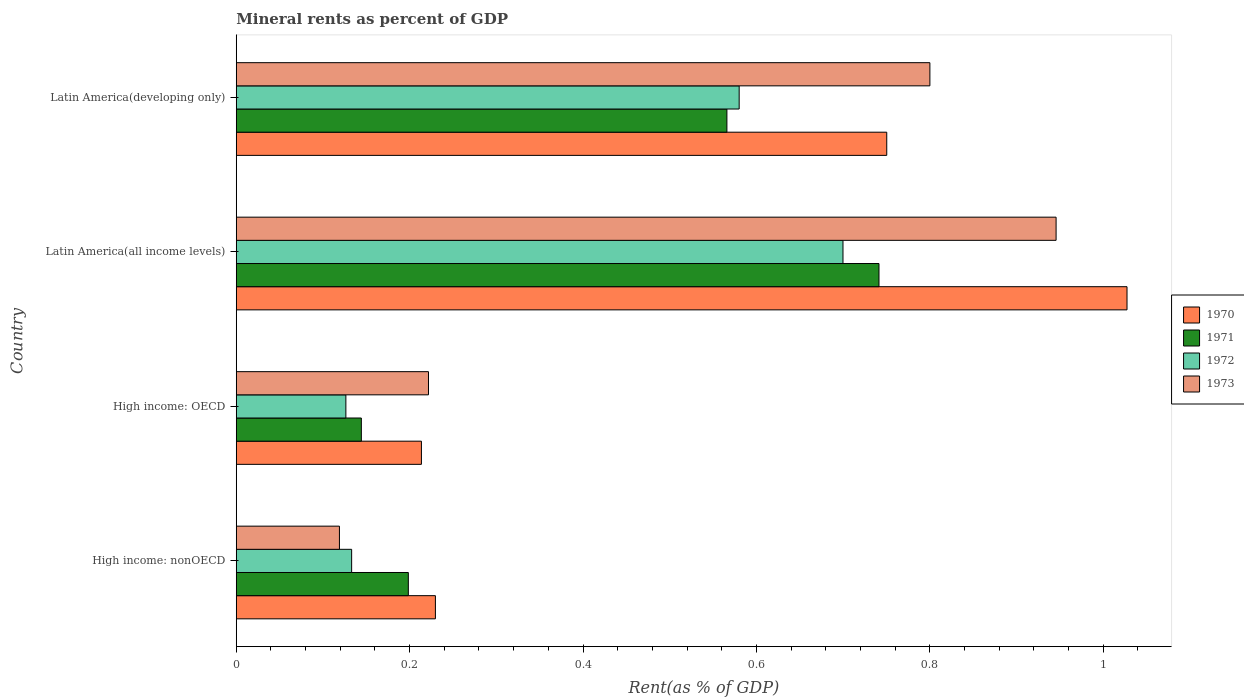Are the number of bars per tick equal to the number of legend labels?
Give a very brief answer. Yes. Are the number of bars on each tick of the Y-axis equal?
Ensure brevity in your answer.  Yes. How many bars are there on the 3rd tick from the top?
Ensure brevity in your answer.  4. What is the label of the 1st group of bars from the top?
Give a very brief answer. Latin America(developing only). In how many cases, is the number of bars for a given country not equal to the number of legend labels?
Keep it short and to the point. 0. What is the mineral rent in 1973 in Latin America(all income levels)?
Your answer should be compact. 0.95. Across all countries, what is the maximum mineral rent in 1971?
Your answer should be compact. 0.74. Across all countries, what is the minimum mineral rent in 1972?
Your answer should be compact. 0.13. In which country was the mineral rent in 1973 maximum?
Give a very brief answer. Latin America(all income levels). In which country was the mineral rent in 1971 minimum?
Give a very brief answer. High income: OECD. What is the total mineral rent in 1971 in the graph?
Provide a succinct answer. 1.65. What is the difference between the mineral rent in 1971 in High income: OECD and that in High income: nonOECD?
Give a very brief answer. -0.05. What is the difference between the mineral rent in 1970 in Latin America(developing only) and the mineral rent in 1972 in High income: nonOECD?
Your answer should be compact. 0.62. What is the average mineral rent in 1970 per country?
Make the answer very short. 0.56. What is the difference between the mineral rent in 1971 and mineral rent in 1972 in Latin America(all income levels)?
Provide a short and direct response. 0.04. What is the ratio of the mineral rent in 1971 in Latin America(all income levels) to that in Latin America(developing only)?
Your answer should be compact. 1.31. Is the mineral rent in 1972 in High income: OECD less than that in Latin America(developing only)?
Give a very brief answer. Yes. What is the difference between the highest and the second highest mineral rent in 1973?
Provide a short and direct response. 0.15. What is the difference between the highest and the lowest mineral rent in 1972?
Give a very brief answer. 0.57. In how many countries, is the mineral rent in 1973 greater than the average mineral rent in 1973 taken over all countries?
Provide a short and direct response. 2. Is the sum of the mineral rent in 1973 in High income: OECD and Latin America(all income levels) greater than the maximum mineral rent in 1972 across all countries?
Keep it short and to the point. Yes. What does the 3rd bar from the top in Latin America(all income levels) represents?
Make the answer very short. 1971. Is it the case that in every country, the sum of the mineral rent in 1971 and mineral rent in 1973 is greater than the mineral rent in 1972?
Your answer should be very brief. Yes. How many countries are there in the graph?
Provide a succinct answer. 4. What is the difference between two consecutive major ticks on the X-axis?
Keep it short and to the point. 0.2. Are the values on the major ticks of X-axis written in scientific E-notation?
Your response must be concise. No. Does the graph contain any zero values?
Provide a succinct answer. No. Where does the legend appear in the graph?
Provide a succinct answer. Center right. How many legend labels are there?
Make the answer very short. 4. How are the legend labels stacked?
Your answer should be very brief. Vertical. What is the title of the graph?
Your response must be concise. Mineral rents as percent of GDP. Does "1982" appear as one of the legend labels in the graph?
Make the answer very short. No. What is the label or title of the X-axis?
Offer a very short reply. Rent(as % of GDP). What is the label or title of the Y-axis?
Give a very brief answer. Country. What is the Rent(as % of GDP) of 1970 in High income: nonOECD?
Your response must be concise. 0.23. What is the Rent(as % of GDP) in 1971 in High income: nonOECD?
Keep it short and to the point. 0.2. What is the Rent(as % of GDP) of 1972 in High income: nonOECD?
Your answer should be very brief. 0.13. What is the Rent(as % of GDP) in 1973 in High income: nonOECD?
Offer a very short reply. 0.12. What is the Rent(as % of GDP) of 1970 in High income: OECD?
Give a very brief answer. 0.21. What is the Rent(as % of GDP) of 1971 in High income: OECD?
Make the answer very short. 0.14. What is the Rent(as % of GDP) in 1972 in High income: OECD?
Ensure brevity in your answer.  0.13. What is the Rent(as % of GDP) of 1973 in High income: OECD?
Make the answer very short. 0.22. What is the Rent(as % of GDP) in 1970 in Latin America(all income levels)?
Offer a very short reply. 1.03. What is the Rent(as % of GDP) of 1971 in Latin America(all income levels)?
Your response must be concise. 0.74. What is the Rent(as % of GDP) of 1972 in Latin America(all income levels)?
Ensure brevity in your answer.  0.7. What is the Rent(as % of GDP) of 1973 in Latin America(all income levels)?
Provide a succinct answer. 0.95. What is the Rent(as % of GDP) of 1970 in Latin America(developing only)?
Your answer should be compact. 0.75. What is the Rent(as % of GDP) in 1971 in Latin America(developing only)?
Make the answer very short. 0.57. What is the Rent(as % of GDP) of 1972 in Latin America(developing only)?
Give a very brief answer. 0.58. What is the Rent(as % of GDP) in 1973 in Latin America(developing only)?
Give a very brief answer. 0.8. Across all countries, what is the maximum Rent(as % of GDP) in 1970?
Provide a short and direct response. 1.03. Across all countries, what is the maximum Rent(as % of GDP) of 1971?
Provide a short and direct response. 0.74. Across all countries, what is the maximum Rent(as % of GDP) of 1972?
Give a very brief answer. 0.7. Across all countries, what is the maximum Rent(as % of GDP) in 1973?
Offer a terse response. 0.95. Across all countries, what is the minimum Rent(as % of GDP) of 1970?
Your answer should be compact. 0.21. Across all countries, what is the minimum Rent(as % of GDP) of 1971?
Provide a short and direct response. 0.14. Across all countries, what is the minimum Rent(as % of GDP) of 1972?
Offer a very short reply. 0.13. Across all countries, what is the minimum Rent(as % of GDP) in 1973?
Your answer should be very brief. 0.12. What is the total Rent(as % of GDP) of 1970 in the graph?
Provide a succinct answer. 2.22. What is the total Rent(as % of GDP) in 1971 in the graph?
Make the answer very short. 1.65. What is the total Rent(as % of GDP) in 1972 in the graph?
Give a very brief answer. 1.54. What is the total Rent(as % of GDP) in 1973 in the graph?
Make the answer very short. 2.09. What is the difference between the Rent(as % of GDP) in 1970 in High income: nonOECD and that in High income: OECD?
Your response must be concise. 0.02. What is the difference between the Rent(as % of GDP) of 1971 in High income: nonOECD and that in High income: OECD?
Offer a very short reply. 0.05. What is the difference between the Rent(as % of GDP) of 1972 in High income: nonOECD and that in High income: OECD?
Keep it short and to the point. 0.01. What is the difference between the Rent(as % of GDP) in 1973 in High income: nonOECD and that in High income: OECD?
Offer a very short reply. -0.1. What is the difference between the Rent(as % of GDP) of 1970 in High income: nonOECD and that in Latin America(all income levels)?
Keep it short and to the point. -0.8. What is the difference between the Rent(as % of GDP) in 1971 in High income: nonOECD and that in Latin America(all income levels)?
Offer a terse response. -0.54. What is the difference between the Rent(as % of GDP) of 1972 in High income: nonOECD and that in Latin America(all income levels)?
Give a very brief answer. -0.57. What is the difference between the Rent(as % of GDP) of 1973 in High income: nonOECD and that in Latin America(all income levels)?
Give a very brief answer. -0.83. What is the difference between the Rent(as % of GDP) in 1970 in High income: nonOECD and that in Latin America(developing only)?
Ensure brevity in your answer.  -0.52. What is the difference between the Rent(as % of GDP) of 1971 in High income: nonOECD and that in Latin America(developing only)?
Provide a succinct answer. -0.37. What is the difference between the Rent(as % of GDP) of 1972 in High income: nonOECD and that in Latin America(developing only)?
Your response must be concise. -0.45. What is the difference between the Rent(as % of GDP) of 1973 in High income: nonOECD and that in Latin America(developing only)?
Offer a terse response. -0.68. What is the difference between the Rent(as % of GDP) of 1970 in High income: OECD and that in Latin America(all income levels)?
Your answer should be very brief. -0.81. What is the difference between the Rent(as % of GDP) in 1971 in High income: OECD and that in Latin America(all income levels)?
Provide a succinct answer. -0.6. What is the difference between the Rent(as % of GDP) of 1972 in High income: OECD and that in Latin America(all income levels)?
Your response must be concise. -0.57. What is the difference between the Rent(as % of GDP) in 1973 in High income: OECD and that in Latin America(all income levels)?
Keep it short and to the point. -0.72. What is the difference between the Rent(as % of GDP) in 1970 in High income: OECD and that in Latin America(developing only)?
Give a very brief answer. -0.54. What is the difference between the Rent(as % of GDP) in 1971 in High income: OECD and that in Latin America(developing only)?
Your answer should be very brief. -0.42. What is the difference between the Rent(as % of GDP) in 1972 in High income: OECD and that in Latin America(developing only)?
Offer a terse response. -0.45. What is the difference between the Rent(as % of GDP) of 1973 in High income: OECD and that in Latin America(developing only)?
Your answer should be compact. -0.58. What is the difference between the Rent(as % of GDP) in 1970 in Latin America(all income levels) and that in Latin America(developing only)?
Give a very brief answer. 0.28. What is the difference between the Rent(as % of GDP) of 1971 in Latin America(all income levels) and that in Latin America(developing only)?
Provide a short and direct response. 0.18. What is the difference between the Rent(as % of GDP) of 1972 in Latin America(all income levels) and that in Latin America(developing only)?
Offer a very short reply. 0.12. What is the difference between the Rent(as % of GDP) in 1973 in Latin America(all income levels) and that in Latin America(developing only)?
Your answer should be very brief. 0.15. What is the difference between the Rent(as % of GDP) in 1970 in High income: nonOECD and the Rent(as % of GDP) in 1971 in High income: OECD?
Keep it short and to the point. 0.09. What is the difference between the Rent(as % of GDP) in 1970 in High income: nonOECD and the Rent(as % of GDP) in 1972 in High income: OECD?
Offer a terse response. 0.1. What is the difference between the Rent(as % of GDP) of 1970 in High income: nonOECD and the Rent(as % of GDP) of 1973 in High income: OECD?
Your answer should be very brief. 0.01. What is the difference between the Rent(as % of GDP) in 1971 in High income: nonOECD and the Rent(as % of GDP) in 1972 in High income: OECD?
Offer a very short reply. 0.07. What is the difference between the Rent(as % of GDP) in 1971 in High income: nonOECD and the Rent(as % of GDP) in 1973 in High income: OECD?
Give a very brief answer. -0.02. What is the difference between the Rent(as % of GDP) in 1972 in High income: nonOECD and the Rent(as % of GDP) in 1973 in High income: OECD?
Provide a short and direct response. -0.09. What is the difference between the Rent(as % of GDP) of 1970 in High income: nonOECD and the Rent(as % of GDP) of 1971 in Latin America(all income levels)?
Keep it short and to the point. -0.51. What is the difference between the Rent(as % of GDP) of 1970 in High income: nonOECD and the Rent(as % of GDP) of 1972 in Latin America(all income levels)?
Your answer should be compact. -0.47. What is the difference between the Rent(as % of GDP) in 1970 in High income: nonOECD and the Rent(as % of GDP) in 1973 in Latin America(all income levels)?
Ensure brevity in your answer.  -0.72. What is the difference between the Rent(as % of GDP) of 1971 in High income: nonOECD and the Rent(as % of GDP) of 1972 in Latin America(all income levels)?
Ensure brevity in your answer.  -0.5. What is the difference between the Rent(as % of GDP) in 1971 in High income: nonOECD and the Rent(as % of GDP) in 1973 in Latin America(all income levels)?
Offer a terse response. -0.75. What is the difference between the Rent(as % of GDP) of 1972 in High income: nonOECD and the Rent(as % of GDP) of 1973 in Latin America(all income levels)?
Your answer should be very brief. -0.81. What is the difference between the Rent(as % of GDP) of 1970 in High income: nonOECD and the Rent(as % of GDP) of 1971 in Latin America(developing only)?
Your answer should be compact. -0.34. What is the difference between the Rent(as % of GDP) of 1970 in High income: nonOECD and the Rent(as % of GDP) of 1972 in Latin America(developing only)?
Your response must be concise. -0.35. What is the difference between the Rent(as % of GDP) in 1970 in High income: nonOECD and the Rent(as % of GDP) in 1973 in Latin America(developing only)?
Your response must be concise. -0.57. What is the difference between the Rent(as % of GDP) in 1971 in High income: nonOECD and the Rent(as % of GDP) in 1972 in Latin America(developing only)?
Give a very brief answer. -0.38. What is the difference between the Rent(as % of GDP) of 1971 in High income: nonOECD and the Rent(as % of GDP) of 1973 in Latin America(developing only)?
Provide a short and direct response. -0.6. What is the difference between the Rent(as % of GDP) in 1972 in High income: nonOECD and the Rent(as % of GDP) in 1973 in Latin America(developing only)?
Give a very brief answer. -0.67. What is the difference between the Rent(as % of GDP) of 1970 in High income: OECD and the Rent(as % of GDP) of 1971 in Latin America(all income levels)?
Keep it short and to the point. -0.53. What is the difference between the Rent(as % of GDP) of 1970 in High income: OECD and the Rent(as % of GDP) of 1972 in Latin America(all income levels)?
Make the answer very short. -0.49. What is the difference between the Rent(as % of GDP) of 1970 in High income: OECD and the Rent(as % of GDP) of 1973 in Latin America(all income levels)?
Your answer should be compact. -0.73. What is the difference between the Rent(as % of GDP) in 1971 in High income: OECD and the Rent(as % of GDP) in 1972 in Latin America(all income levels)?
Make the answer very short. -0.56. What is the difference between the Rent(as % of GDP) in 1971 in High income: OECD and the Rent(as % of GDP) in 1973 in Latin America(all income levels)?
Give a very brief answer. -0.8. What is the difference between the Rent(as % of GDP) of 1972 in High income: OECD and the Rent(as % of GDP) of 1973 in Latin America(all income levels)?
Make the answer very short. -0.82. What is the difference between the Rent(as % of GDP) in 1970 in High income: OECD and the Rent(as % of GDP) in 1971 in Latin America(developing only)?
Offer a very short reply. -0.35. What is the difference between the Rent(as % of GDP) in 1970 in High income: OECD and the Rent(as % of GDP) in 1972 in Latin America(developing only)?
Give a very brief answer. -0.37. What is the difference between the Rent(as % of GDP) in 1970 in High income: OECD and the Rent(as % of GDP) in 1973 in Latin America(developing only)?
Your answer should be very brief. -0.59. What is the difference between the Rent(as % of GDP) in 1971 in High income: OECD and the Rent(as % of GDP) in 1972 in Latin America(developing only)?
Make the answer very short. -0.44. What is the difference between the Rent(as % of GDP) in 1971 in High income: OECD and the Rent(as % of GDP) in 1973 in Latin America(developing only)?
Your answer should be compact. -0.66. What is the difference between the Rent(as % of GDP) of 1972 in High income: OECD and the Rent(as % of GDP) of 1973 in Latin America(developing only)?
Give a very brief answer. -0.67. What is the difference between the Rent(as % of GDP) of 1970 in Latin America(all income levels) and the Rent(as % of GDP) of 1971 in Latin America(developing only)?
Ensure brevity in your answer.  0.46. What is the difference between the Rent(as % of GDP) in 1970 in Latin America(all income levels) and the Rent(as % of GDP) in 1972 in Latin America(developing only)?
Your answer should be compact. 0.45. What is the difference between the Rent(as % of GDP) of 1970 in Latin America(all income levels) and the Rent(as % of GDP) of 1973 in Latin America(developing only)?
Your response must be concise. 0.23. What is the difference between the Rent(as % of GDP) in 1971 in Latin America(all income levels) and the Rent(as % of GDP) in 1972 in Latin America(developing only)?
Provide a succinct answer. 0.16. What is the difference between the Rent(as % of GDP) of 1971 in Latin America(all income levels) and the Rent(as % of GDP) of 1973 in Latin America(developing only)?
Keep it short and to the point. -0.06. What is the difference between the Rent(as % of GDP) of 1972 in Latin America(all income levels) and the Rent(as % of GDP) of 1973 in Latin America(developing only)?
Your answer should be very brief. -0.1. What is the average Rent(as % of GDP) in 1970 per country?
Provide a short and direct response. 0.56. What is the average Rent(as % of GDP) in 1971 per country?
Provide a succinct answer. 0.41. What is the average Rent(as % of GDP) in 1972 per country?
Offer a very short reply. 0.38. What is the average Rent(as % of GDP) of 1973 per country?
Provide a short and direct response. 0.52. What is the difference between the Rent(as % of GDP) of 1970 and Rent(as % of GDP) of 1971 in High income: nonOECD?
Offer a terse response. 0.03. What is the difference between the Rent(as % of GDP) in 1970 and Rent(as % of GDP) in 1972 in High income: nonOECD?
Provide a succinct answer. 0.1. What is the difference between the Rent(as % of GDP) in 1970 and Rent(as % of GDP) in 1973 in High income: nonOECD?
Ensure brevity in your answer.  0.11. What is the difference between the Rent(as % of GDP) of 1971 and Rent(as % of GDP) of 1972 in High income: nonOECD?
Keep it short and to the point. 0.07. What is the difference between the Rent(as % of GDP) in 1971 and Rent(as % of GDP) in 1973 in High income: nonOECD?
Make the answer very short. 0.08. What is the difference between the Rent(as % of GDP) of 1972 and Rent(as % of GDP) of 1973 in High income: nonOECD?
Your response must be concise. 0.01. What is the difference between the Rent(as % of GDP) of 1970 and Rent(as % of GDP) of 1971 in High income: OECD?
Your answer should be very brief. 0.07. What is the difference between the Rent(as % of GDP) in 1970 and Rent(as % of GDP) in 1972 in High income: OECD?
Your answer should be compact. 0.09. What is the difference between the Rent(as % of GDP) in 1970 and Rent(as % of GDP) in 1973 in High income: OECD?
Provide a short and direct response. -0.01. What is the difference between the Rent(as % of GDP) in 1971 and Rent(as % of GDP) in 1972 in High income: OECD?
Provide a succinct answer. 0.02. What is the difference between the Rent(as % of GDP) in 1971 and Rent(as % of GDP) in 1973 in High income: OECD?
Keep it short and to the point. -0.08. What is the difference between the Rent(as % of GDP) in 1972 and Rent(as % of GDP) in 1973 in High income: OECD?
Make the answer very short. -0.1. What is the difference between the Rent(as % of GDP) of 1970 and Rent(as % of GDP) of 1971 in Latin America(all income levels)?
Make the answer very short. 0.29. What is the difference between the Rent(as % of GDP) in 1970 and Rent(as % of GDP) in 1972 in Latin America(all income levels)?
Give a very brief answer. 0.33. What is the difference between the Rent(as % of GDP) in 1970 and Rent(as % of GDP) in 1973 in Latin America(all income levels)?
Ensure brevity in your answer.  0.08. What is the difference between the Rent(as % of GDP) of 1971 and Rent(as % of GDP) of 1972 in Latin America(all income levels)?
Provide a short and direct response. 0.04. What is the difference between the Rent(as % of GDP) of 1971 and Rent(as % of GDP) of 1973 in Latin America(all income levels)?
Your answer should be compact. -0.2. What is the difference between the Rent(as % of GDP) in 1972 and Rent(as % of GDP) in 1973 in Latin America(all income levels)?
Offer a very short reply. -0.25. What is the difference between the Rent(as % of GDP) in 1970 and Rent(as % of GDP) in 1971 in Latin America(developing only)?
Your answer should be compact. 0.18. What is the difference between the Rent(as % of GDP) in 1970 and Rent(as % of GDP) in 1972 in Latin America(developing only)?
Your answer should be compact. 0.17. What is the difference between the Rent(as % of GDP) of 1970 and Rent(as % of GDP) of 1973 in Latin America(developing only)?
Your response must be concise. -0.05. What is the difference between the Rent(as % of GDP) of 1971 and Rent(as % of GDP) of 1972 in Latin America(developing only)?
Provide a succinct answer. -0.01. What is the difference between the Rent(as % of GDP) of 1971 and Rent(as % of GDP) of 1973 in Latin America(developing only)?
Your answer should be very brief. -0.23. What is the difference between the Rent(as % of GDP) of 1972 and Rent(as % of GDP) of 1973 in Latin America(developing only)?
Your response must be concise. -0.22. What is the ratio of the Rent(as % of GDP) of 1970 in High income: nonOECD to that in High income: OECD?
Keep it short and to the point. 1.08. What is the ratio of the Rent(as % of GDP) of 1971 in High income: nonOECD to that in High income: OECD?
Provide a short and direct response. 1.38. What is the ratio of the Rent(as % of GDP) in 1972 in High income: nonOECD to that in High income: OECD?
Keep it short and to the point. 1.05. What is the ratio of the Rent(as % of GDP) in 1973 in High income: nonOECD to that in High income: OECD?
Your response must be concise. 0.54. What is the ratio of the Rent(as % of GDP) of 1970 in High income: nonOECD to that in Latin America(all income levels)?
Your response must be concise. 0.22. What is the ratio of the Rent(as % of GDP) in 1971 in High income: nonOECD to that in Latin America(all income levels)?
Provide a short and direct response. 0.27. What is the ratio of the Rent(as % of GDP) of 1972 in High income: nonOECD to that in Latin America(all income levels)?
Offer a terse response. 0.19. What is the ratio of the Rent(as % of GDP) of 1973 in High income: nonOECD to that in Latin America(all income levels)?
Your answer should be compact. 0.13. What is the ratio of the Rent(as % of GDP) in 1970 in High income: nonOECD to that in Latin America(developing only)?
Keep it short and to the point. 0.31. What is the ratio of the Rent(as % of GDP) of 1971 in High income: nonOECD to that in Latin America(developing only)?
Provide a succinct answer. 0.35. What is the ratio of the Rent(as % of GDP) in 1972 in High income: nonOECD to that in Latin America(developing only)?
Your answer should be compact. 0.23. What is the ratio of the Rent(as % of GDP) of 1973 in High income: nonOECD to that in Latin America(developing only)?
Provide a succinct answer. 0.15. What is the ratio of the Rent(as % of GDP) of 1970 in High income: OECD to that in Latin America(all income levels)?
Your answer should be compact. 0.21. What is the ratio of the Rent(as % of GDP) of 1971 in High income: OECD to that in Latin America(all income levels)?
Ensure brevity in your answer.  0.19. What is the ratio of the Rent(as % of GDP) of 1972 in High income: OECD to that in Latin America(all income levels)?
Your response must be concise. 0.18. What is the ratio of the Rent(as % of GDP) in 1973 in High income: OECD to that in Latin America(all income levels)?
Offer a terse response. 0.23. What is the ratio of the Rent(as % of GDP) of 1970 in High income: OECD to that in Latin America(developing only)?
Ensure brevity in your answer.  0.28. What is the ratio of the Rent(as % of GDP) in 1971 in High income: OECD to that in Latin America(developing only)?
Ensure brevity in your answer.  0.26. What is the ratio of the Rent(as % of GDP) of 1972 in High income: OECD to that in Latin America(developing only)?
Keep it short and to the point. 0.22. What is the ratio of the Rent(as % of GDP) in 1973 in High income: OECD to that in Latin America(developing only)?
Your response must be concise. 0.28. What is the ratio of the Rent(as % of GDP) in 1970 in Latin America(all income levels) to that in Latin America(developing only)?
Ensure brevity in your answer.  1.37. What is the ratio of the Rent(as % of GDP) in 1971 in Latin America(all income levels) to that in Latin America(developing only)?
Your answer should be very brief. 1.31. What is the ratio of the Rent(as % of GDP) in 1972 in Latin America(all income levels) to that in Latin America(developing only)?
Provide a succinct answer. 1.21. What is the ratio of the Rent(as % of GDP) of 1973 in Latin America(all income levels) to that in Latin America(developing only)?
Ensure brevity in your answer.  1.18. What is the difference between the highest and the second highest Rent(as % of GDP) of 1970?
Your response must be concise. 0.28. What is the difference between the highest and the second highest Rent(as % of GDP) of 1971?
Provide a succinct answer. 0.18. What is the difference between the highest and the second highest Rent(as % of GDP) of 1972?
Your answer should be compact. 0.12. What is the difference between the highest and the second highest Rent(as % of GDP) of 1973?
Your answer should be very brief. 0.15. What is the difference between the highest and the lowest Rent(as % of GDP) of 1970?
Keep it short and to the point. 0.81. What is the difference between the highest and the lowest Rent(as % of GDP) of 1971?
Your answer should be very brief. 0.6. What is the difference between the highest and the lowest Rent(as % of GDP) in 1972?
Provide a short and direct response. 0.57. What is the difference between the highest and the lowest Rent(as % of GDP) of 1973?
Give a very brief answer. 0.83. 